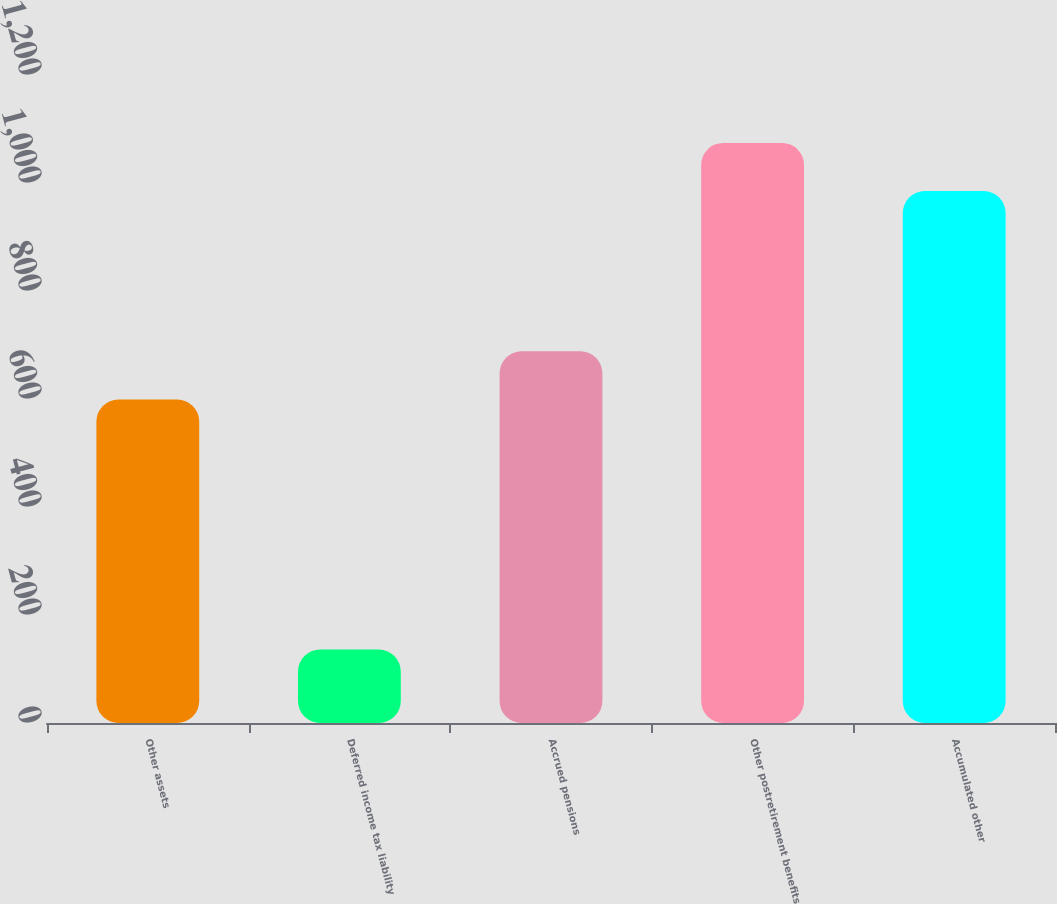Convert chart to OTSL. <chart><loc_0><loc_0><loc_500><loc_500><bar_chart><fcel>Other assets<fcel>Deferred income tax liability<fcel>Accrued pensions<fcel>Other postretirement benefits<fcel>Accumulated other<nl><fcel>599<fcel>136<fcel>688.2<fcel>1074.2<fcel>985<nl></chart> 